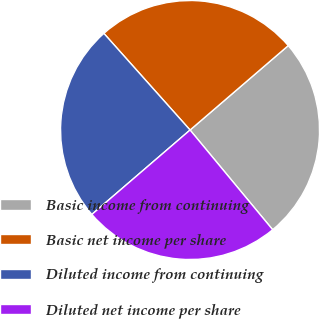Convert chart to OTSL. <chart><loc_0><loc_0><loc_500><loc_500><pie_chart><fcel>Basic income from continuing<fcel>Basic net income per share<fcel>Diluted income from continuing<fcel>Diluted net income per share<nl><fcel>25.29%<fcel>25.29%<fcel>24.71%<fcel>24.71%<nl></chart> 